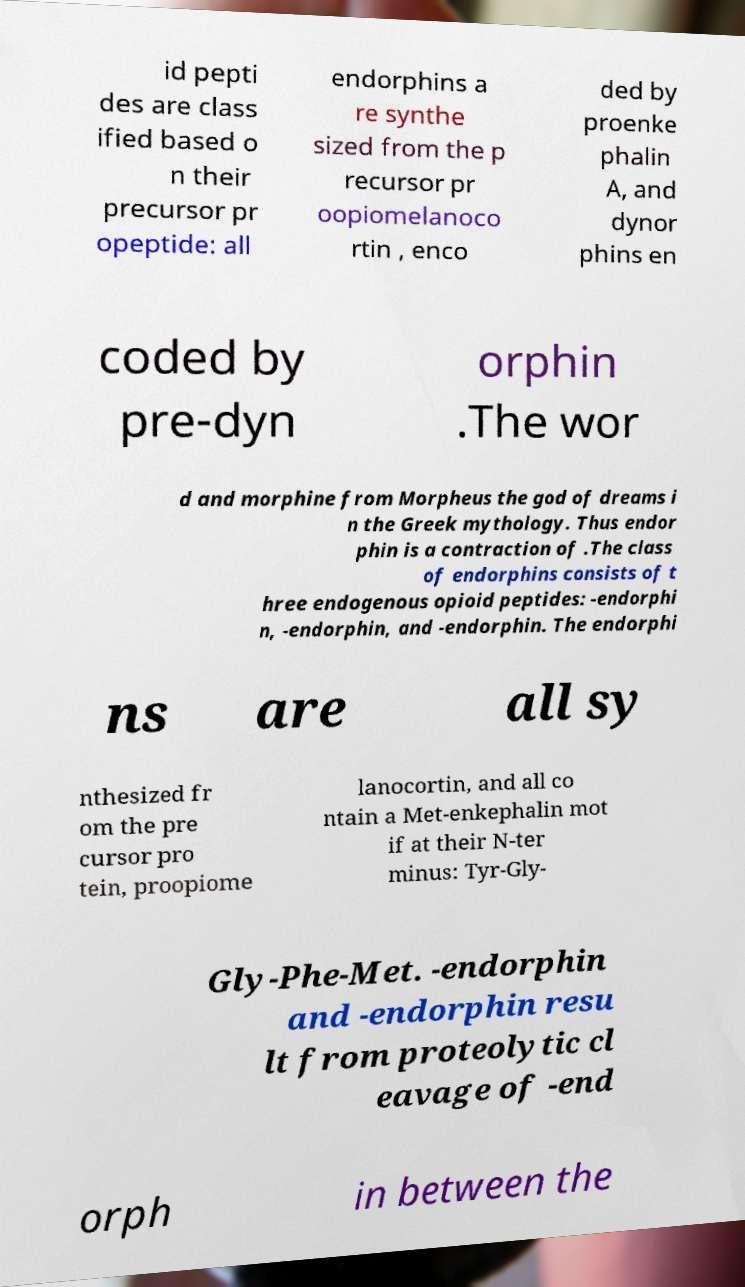I need the written content from this picture converted into text. Can you do that? id pepti des are class ified based o n their precursor pr opeptide: all endorphins a re synthe sized from the p recursor pr oopiomelanoco rtin , enco ded by proenke phalin A, and dynor phins en coded by pre-dyn orphin .The wor d and morphine from Morpheus the god of dreams i n the Greek mythology. Thus endor phin is a contraction of .The class of endorphins consists of t hree endogenous opioid peptides: -endorphi n, -endorphin, and -endorphin. The endorphi ns are all sy nthesized fr om the pre cursor pro tein, proopiome lanocortin, and all co ntain a Met-enkephalin mot if at their N-ter minus: Tyr-Gly- Gly-Phe-Met. -endorphin and -endorphin resu lt from proteolytic cl eavage of -end orph in between the 